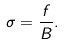<formula> <loc_0><loc_0><loc_500><loc_500>\sigma = \frac { f } { B } .</formula> 